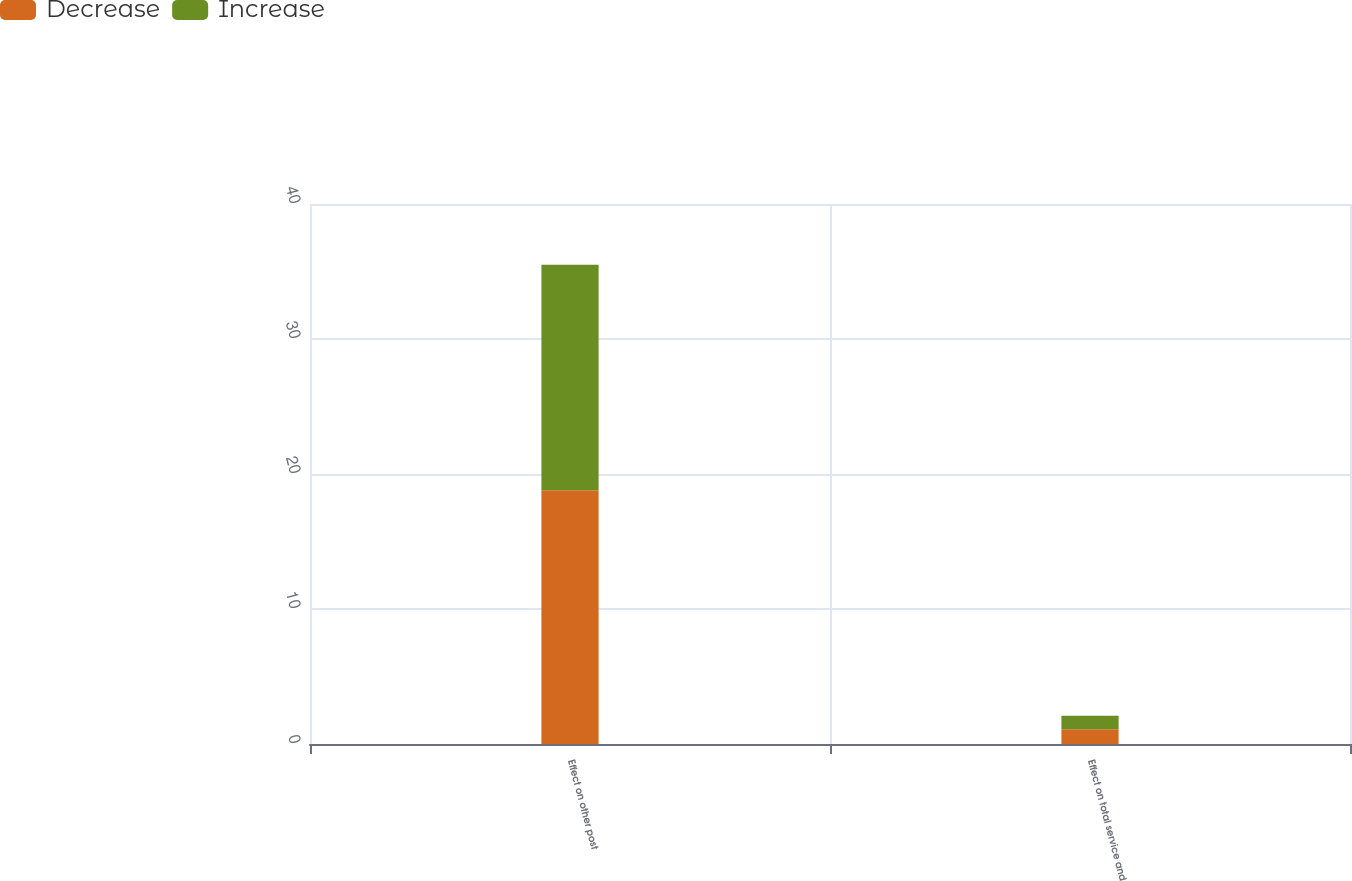<chart> <loc_0><loc_0><loc_500><loc_500><stacked_bar_chart><ecel><fcel>Effect on other post<fcel>Effect on total service and<nl><fcel>Decrease<fcel>18.8<fcel>1.1<nl><fcel>Increase<fcel>16.7<fcel>1<nl></chart> 